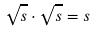Convert formula to latex. <formula><loc_0><loc_0><loc_500><loc_500>\sqrt { s } \cdot \sqrt { s } = s</formula> 